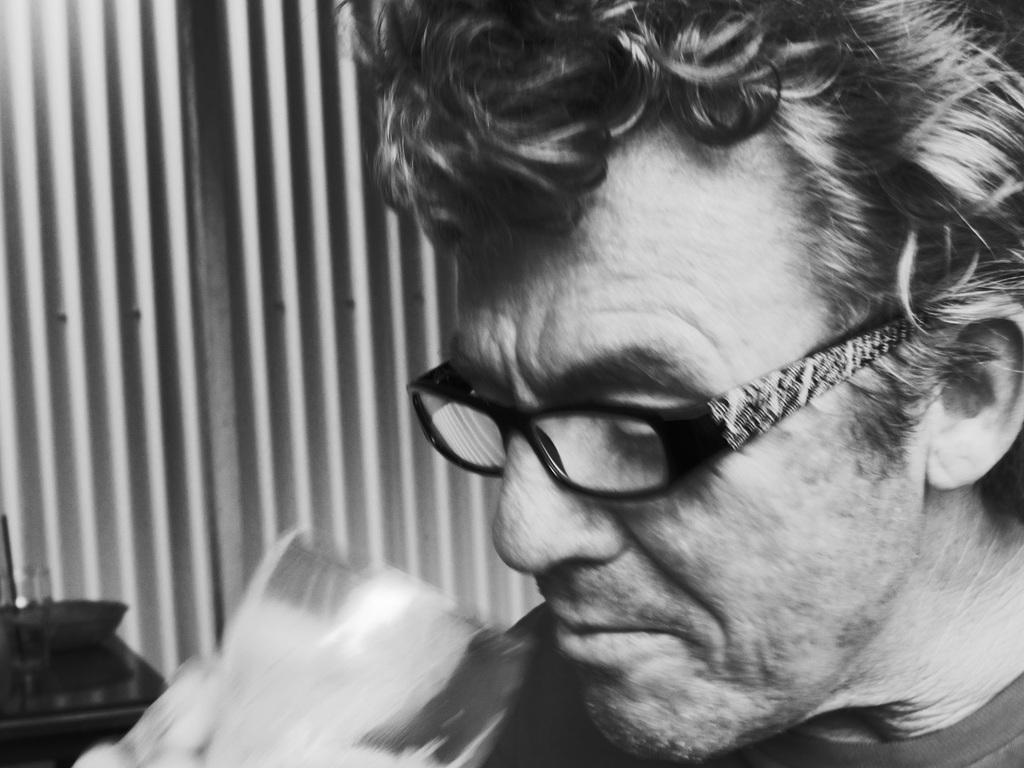Could you give a brief overview of what you see in this image? This is a black and white image, in this image. On the right side, we can see a man holding a glass in his hand. On the left side, we can also see a table. In the background, we can see a grill window. 